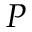Convert formula to latex. <formula><loc_0><loc_0><loc_500><loc_500>P</formula> 